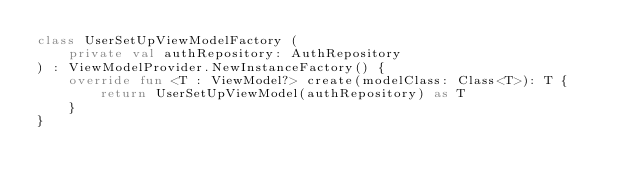<code> <loc_0><loc_0><loc_500><loc_500><_Kotlin_>class UserSetUpViewModelFactory (
    private val authRepository: AuthRepository
) : ViewModelProvider.NewInstanceFactory() {
    override fun <T : ViewModel?> create(modelClass: Class<T>): T {
        return UserSetUpViewModel(authRepository) as T
    }
}</code> 